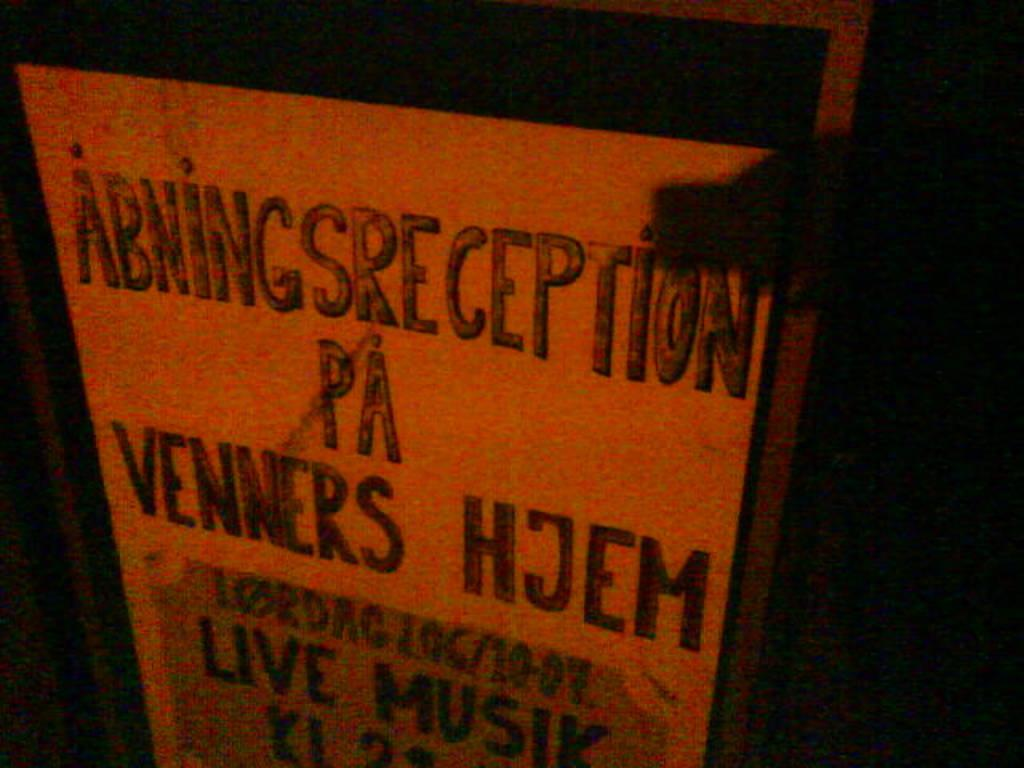<image>
Give a short and clear explanation of the subsequent image. A handwritten sign in a foreign language advertising live music. 